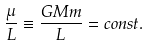<formula> <loc_0><loc_0><loc_500><loc_500>\frac { \mu } { L } \equiv \frac { G M m } { L } = c o n s t .</formula> 